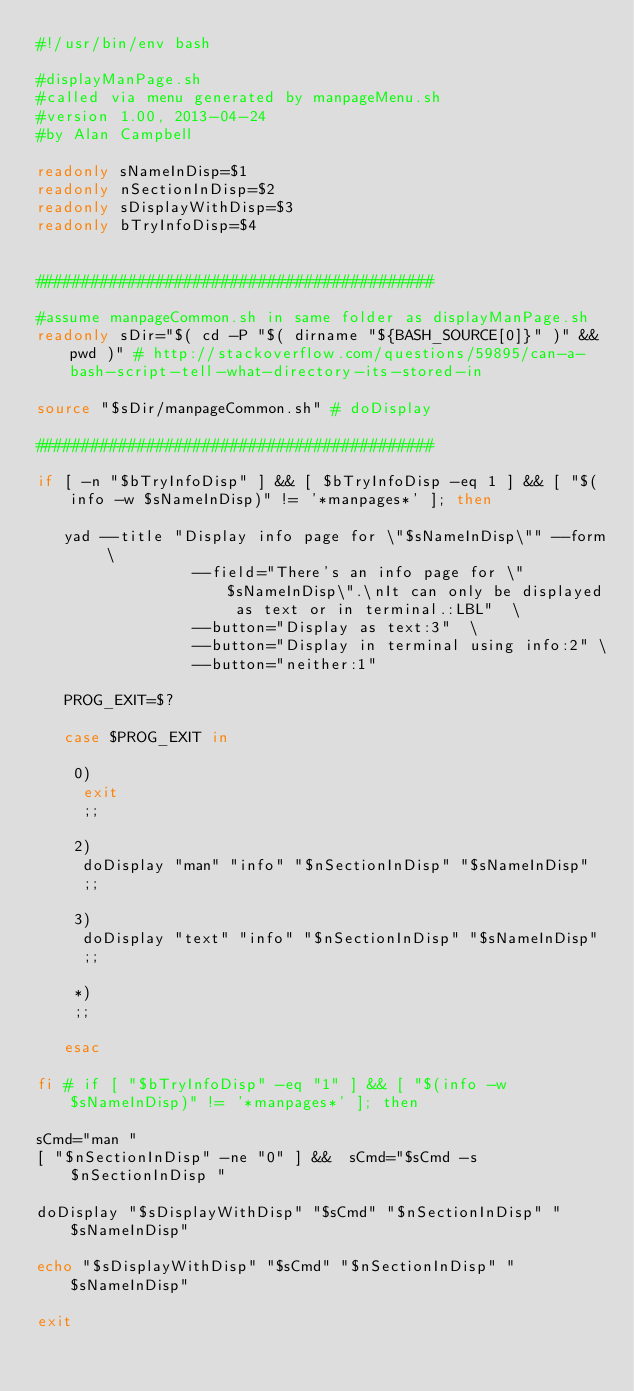Convert code to text. <code><loc_0><loc_0><loc_500><loc_500><_Bash_>#!/usr/bin/env bash

#displayManPage.sh
#called via menu generated by manpageMenu.sh
#version 1.00, 2013-04-24
#by Alan Campbell

readonly sNameInDisp=$1
readonly nSectionInDisp=$2
readonly sDisplayWithDisp=$3
readonly bTryInfoDisp=$4


###########################################

#assume manpageCommon.sh in same folder as displayManPage.sh
readonly sDir="$( cd -P "$( dirname "${BASH_SOURCE[0]}" )" && pwd )" # http://stackoverflow.com/questions/59895/can-a-bash-script-tell-what-directory-its-stored-in

source "$sDir/manpageCommon.sh" # doDisplay

###########################################

if [ -n "$bTryInfoDisp" ] && [ $bTryInfoDisp -eq 1 ] && [ "$(info -w $sNameInDisp)" != '*manpages*' ]; then
 
   yad --title "Display info page for \"$sNameInDisp\"" --form \
                 --field="There's an info page for \"$sNameInDisp\".\nIt can only be displayed as text or in terminal.:LBL"  \
                 --button="Display as text:3"  \
                 --button="Display in terminal using info:2" \
                 --button="neither:1"

   PROG_EXIT=$?

   case $PROG_EXIT in

    0)
     exit
     ;;

    2)
     doDisplay "man" "info" "$nSectionInDisp" "$sNameInDisp"
     ;;

    3)
     doDisplay "text" "info" "$nSectionInDisp" "$sNameInDisp"
     ;;

    *)
    ;;
    
   esac

fi # if [ "$bTryInfoDisp" -eq "1" ] && [ "$(info -w $sNameInDisp)" != '*manpages*' ]; then

sCmd="man "
[ "$nSectionInDisp" -ne "0" ] &&  sCmd="$sCmd -s $nSectionInDisp "

doDisplay "$sDisplayWithDisp" "$sCmd" "$nSectionInDisp" "$sNameInDisp"

echo "$sDisplayWithDisp" "$sCmd" "$nSectionInDisp" "$sNameInDisp"

exit

</code> 